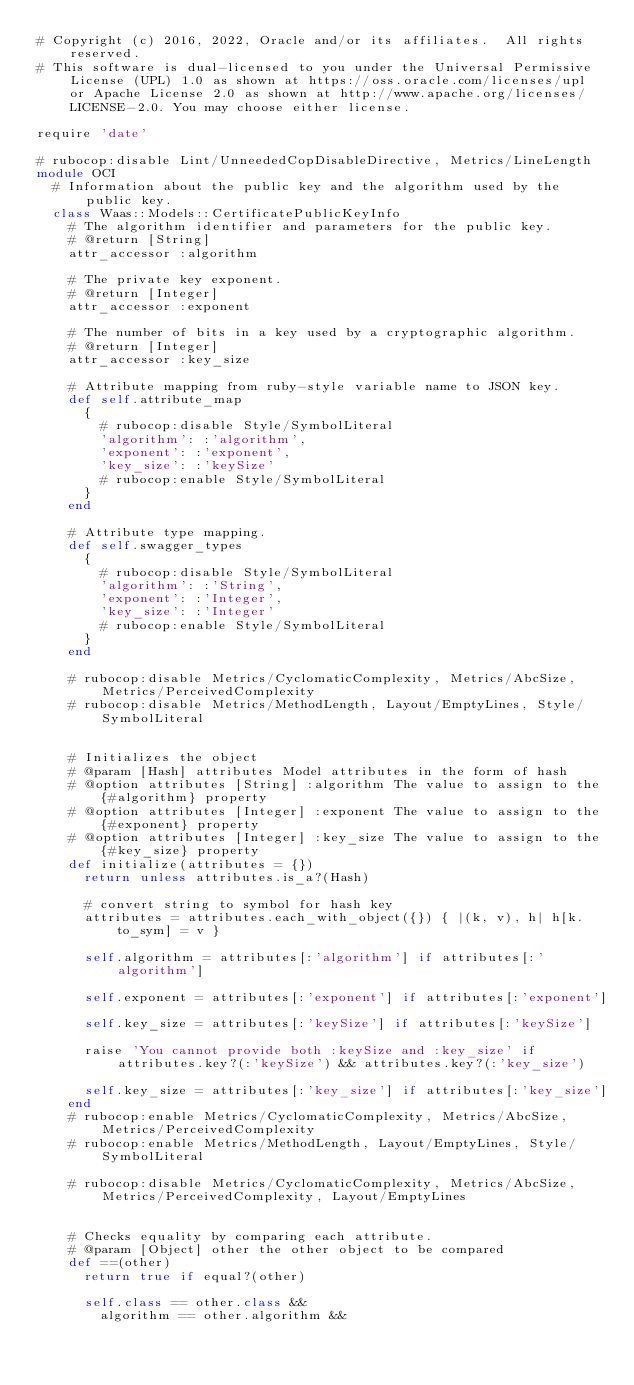Convert code to text. <code><loc_0><loc_0><loc_500><loc_500><_Ruby_># Copyright (c) 2016, 2022, Oracle and/or its affiliates.  All rights reserved.
# This software is dual-licensed to you under the Universal Permissive License (UPL) 1.0 as shown at https://oss.oracle.com/licenses/upl or Apache License 2.0 as shown at http://www.apache.org/licenses/LICENSE-2.0. You may choose either license.

require 'date'

# rubocop:disable Lint/UnneededCopDisableDirective, Metrics/LineLength
module OCI
  # Information about the public key and the algorithm used by the public key.
  class Waas::Models::CertificatePublicKeyInfo
    # The algorithm identifier and parameters for the public key.
    # @return [String]
    attr_accessor :algorithm

    # The private key exponent.
    # @return [Integer]
    attr_accessor :exponent

    # The number of bits in a key used by a cryptographic algorithm.
    # @return [Integer]
    attr_accessor :key_size

    # Attribute mapping from ruby-style variable name to JSON key.
    def self.attribute_map
      {
        # rubocop:disable Style/SymbolLiteral
        'algorithm': :'algorithm',
        'exponent': :'exponent',
        'key_size': :'keySize'
        # rubocop:enable Style/SymbolLiteral
      }
    end

    # Attribute type mapping.
    def self.swagger_types
      {
        # rubocop:disable Style/SymbolLiteral
        'algorithm': :'String',
        'exponent': :'Integer',
        'key_size': :'Integer'
        # rubocop:enable Style/SymbolLiteral
      }
    end

    # rubocop:disable Metrics/CyclomaticComplexity, Metrics/AbcSize, Metrics/PerceivedComplexity
    # rubocop:disable Metrics/MethodLength, Layout/EmptyLines, Style/SymbolLiteral


    # Initializes the object
    # @param [Hash] attributes Model attributes in the form of hash
    # @option attributes [String] :algorithm The value to assign to the {#algorithm} property
    # @option attributes [Integer] :exponent The value to assign to the {#exponent} property
    # @option attributes [Integer] :key_size The value to assign to the {#key_size} property
    def initialize(attributes = {})
      return unless attributes.is_a?(Hash)

      # convert string to symbol for hash key
      attributes = attributes.each_with_object({}) { |(k, v), h| h[k.to_sym] = v }

      self.algorithm = attributes[:'algorithm'] if attributes[:'algorithm']

      self.exponent = attributes[:'exponent'] if attributes[:'exponent']

      self.key_size = attributes[:'keySize'] if attributes[:'keySize']

      raise 'You cannot provide both :keySize and :key_size' if attributes.key?(:'keySize') && attributes.key?(:'key_size')

      self.key_size = attributes[:'key_size'] if attributes[:'key_size']
    end
    # rubocop:enable Metrics/CyclomaticComplexity, Metrics/AbcSize, Metrics/PerceivedComplexity
    # rubocop:enable Metrics/MethodLength, Layout/EmptyLines, Style/SymbolLiteral

    # rubocop:disable Metrics/CyclomaticComplexity, Metrics/AbcSize, Metrics/PerceivedComplexity, Layout/EmptyLines


    # Checks equality by comparing each attribute.
    # @param [Object] other the other object to be compared
    def ==(other)
      return true if equal?(other)

      self.class == other.class &&
        algorithm == other.algorithm &&</code> 